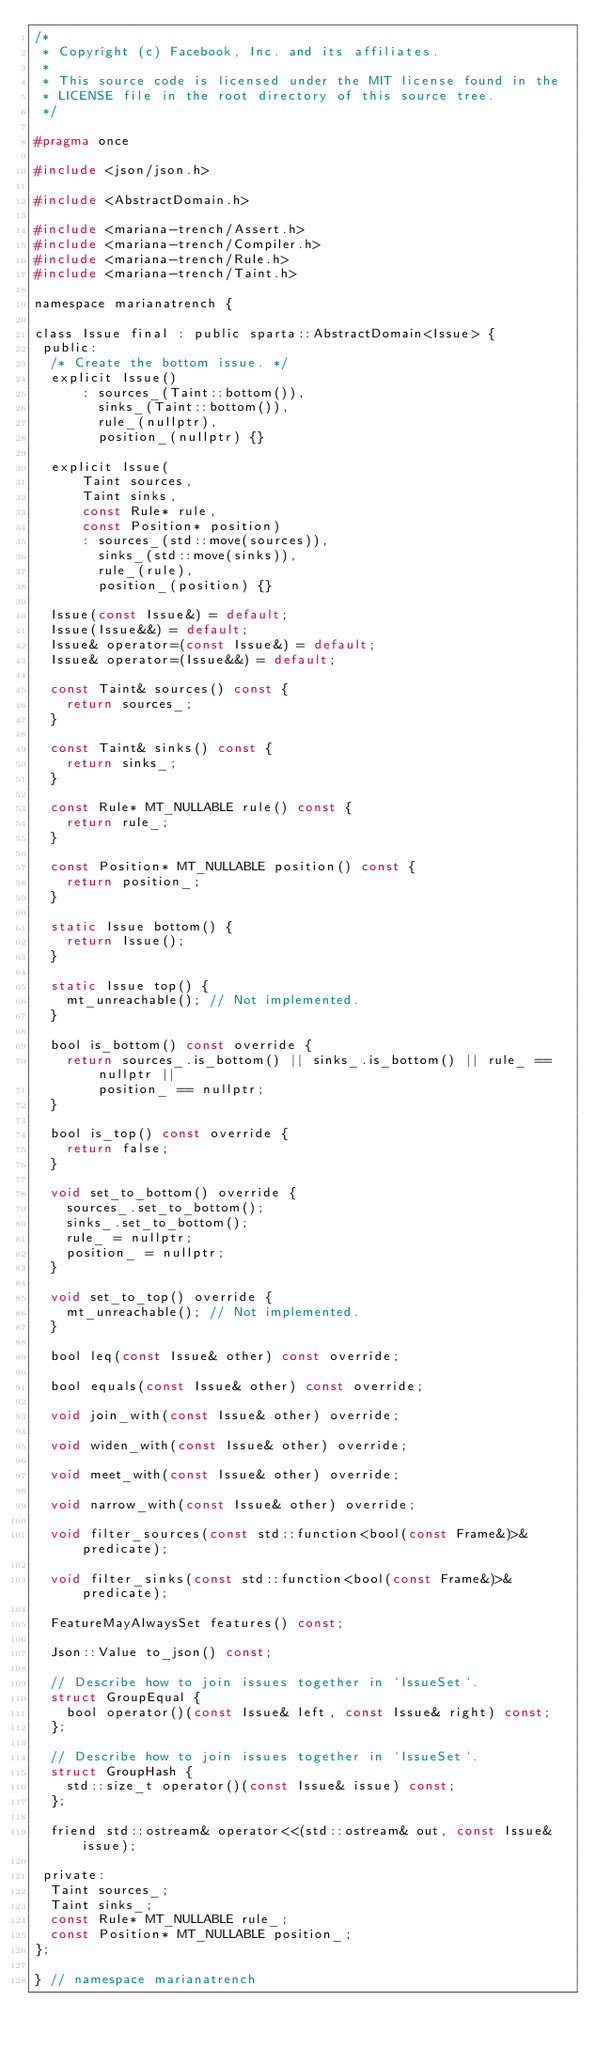Convert code to text. <code><loc_0><loc_0><loc_500><loc_500><_C_>/*
 * Copyright (c) Facebook, Inc. and its affiliates.
 *
 * This source code is licensed under the MIT license found in the
 * LICENSE file in the root directory of this source tree.
 */

#pragma once

#include <json/json.h>

#include <AbstractDomain.h>

#include <mariana-trench/Assert.h>
#include <mariana-trench/Compiler.h>
#include <mariana-trench/Rule.h>
#include <mariana-trench/Taint.h>

namespace marianatrench {

class Issue final : public sparta::AbstractDomain<Issue> {
 public:
  /* Create the bottom issue. */
  explicit Issue()
      : sources_(Taint::bottom()),
        sinks_(Taint::bottom()),
        rule_(nullptr),
        position_(nullptr) {}

  explicit Issue(
      Taint sources,
      Taint sinks,
      const Rule* rule,
      const Position* position)
      : sources_(std::move(sources)),
        sinks_(std::move(sinks)),
        rule_(rule),
        position_(position) {}

  Issue(const Issue&) = default;
  Issue(Issue&&) = default;
  Issue& operator=(const Issue&) = default;
  Issue& operator=(Issue&&) = default;

  const Taint& sources() const {
    return sources_;
  }

  const Taint& sinks() const {
    return sinks_;
  }

  const Rule* MT_NULLABLE rule() const {
    return rule_;
  }

  const Position* MT_NULLABLE position() const {
    return position_;
  }

  static Issue bottom() {
    return Issue();
  }

  static Issue top() {
    mt_unreachable(); // Not implemented.
  }

  bool is_bottom() const override {
    return sources_.is_bottom() || sinks_.is_bottom() || rule_ == nullptr ||
        position_ == nullptr;
  }

  bool is_top() const override {
    return false;
  }

  void set_to_bottom() override {
    sources_.set_to_bottom();
    sinks_.set_to_bottom();
    rule_ = nullptr;
    position_ = nullptr;
  }

  void set_to_top() override {
    mt_unreachable(); // Not implemented.
  }

  bool leq(const Issue& other) const override;

  bool equals(const Issue& other) const override;

  void join_with(const Issue& other) override;

  void widen_with(const Issue& other) override;

  void meet_with(const Issue& other) override;

  void narrow_with(const Issue& other) override;

  void filter_sources(const std::function<bool(const Frame&)>& predicate);

  void filter_sinks(const std::function<bool(const Frame&)>& predicate);

  FeatureMayAlwaysSet features() const;

  Json::Value to_json() const;

  // Describe how to join issues together in `IssueSet`.
  struct GroupEqual {
    bool operator()(const Issue& left, const Issue& right) const;
  };

  // Describe how to join issues together in `IssueSet`.
  struct GroupHash {
    std::size_t operator()(const Issue& issue) const;
  };

  friend std::ostream& operator<<(std::ostream& out, const Issue& issue);

 private:
  Taint sources_;
  Taint sinks_;
  const Rule* MT_NULLABLE rule_;
  const Position* MT_NULLABLE position_;
};

} // namespace marianatrench
</code> 